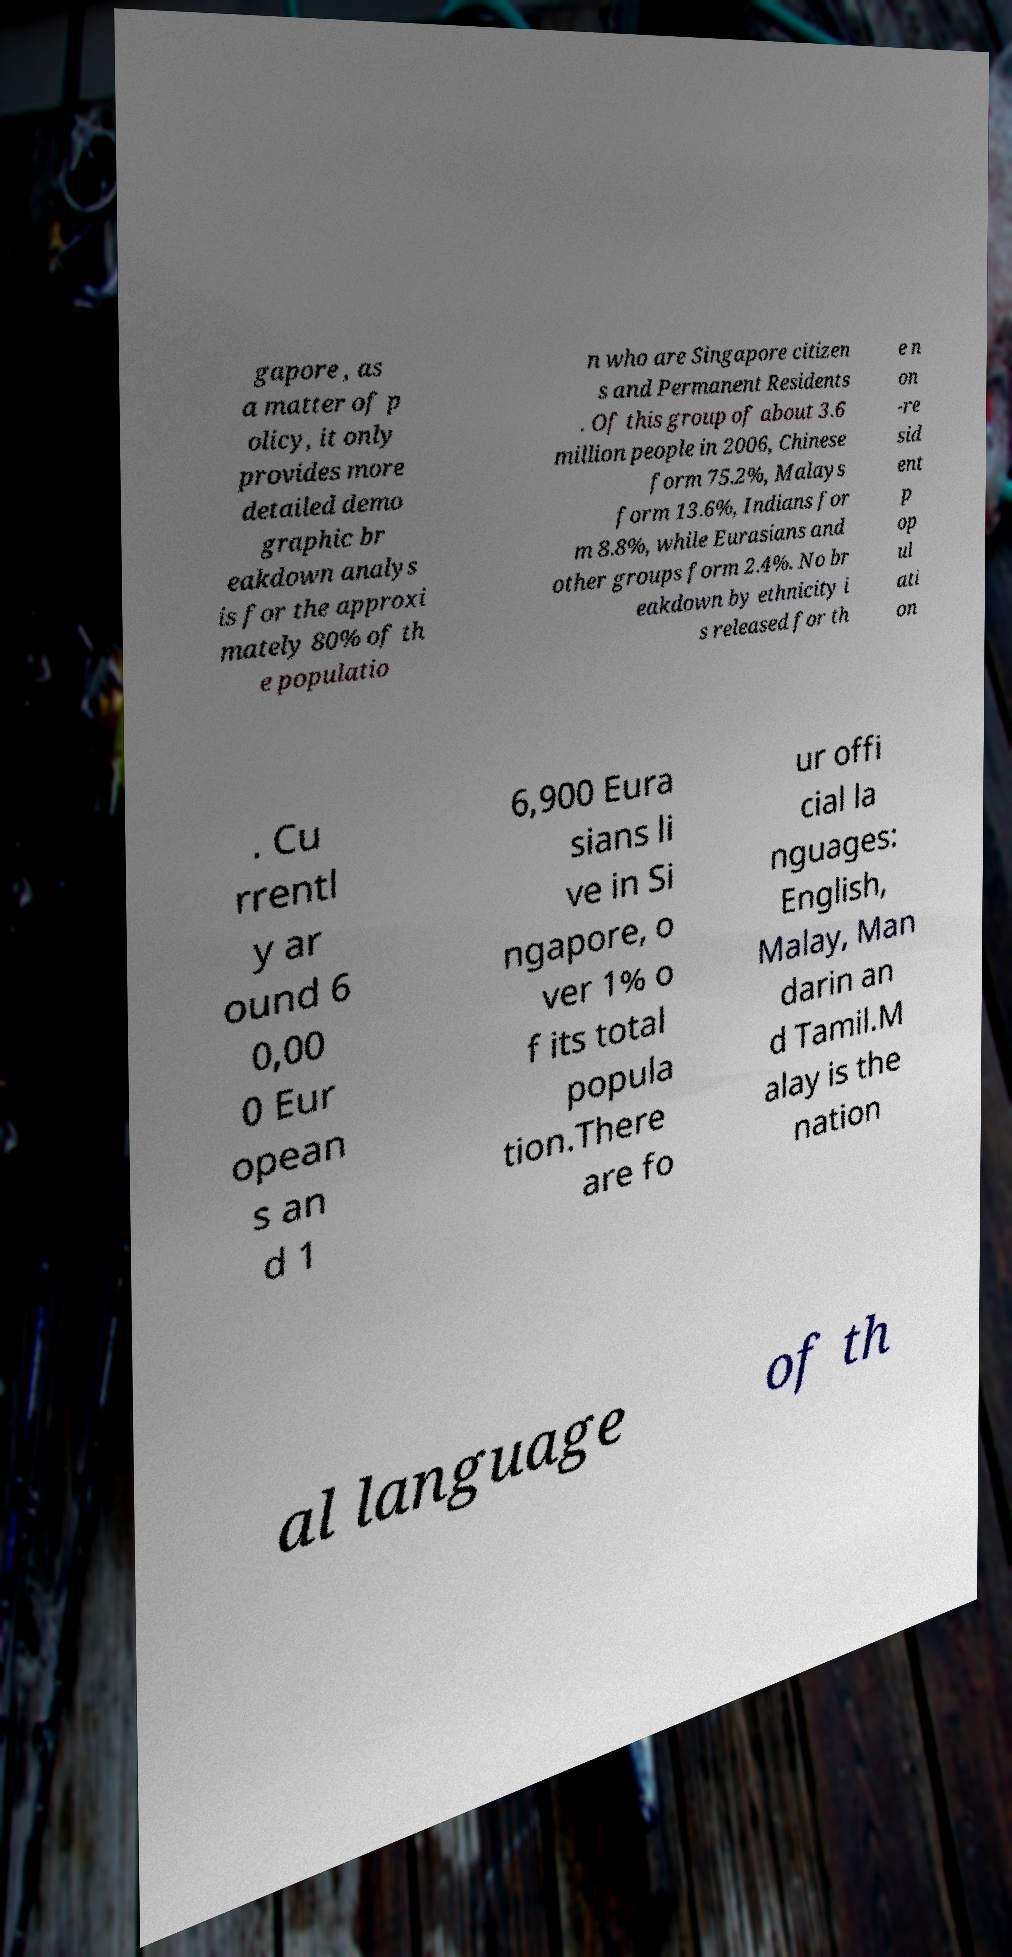I need the written content from this picture converted into text. Can you do that? gapore , as a matter of p olicy, it only provides more detailed demo graphic br eakdown analys is for the approxi mately 80% of th e populatio n who are Singapore citizen s and Permanent Residents . Of this group of about 3.6 million people in 2006, Chinese form 75.2%, Malays form 13.6%, Indians for m 8.8%, while Eurasians and other groups form 2.4%. No br eakdown by ethnicity i s released for th e n on -re sid ent p op ul ati on . Cu rrentl y ar ound 6 0,00 0 Eur opean s an d 1 6,900 Eura sians li ve in Si ngapore, o ver 1% o f its total popula tion.There are fo ur offi cial la nguages: English, Malay, Man darin an d Tamil.M alay is the nation al language of th 